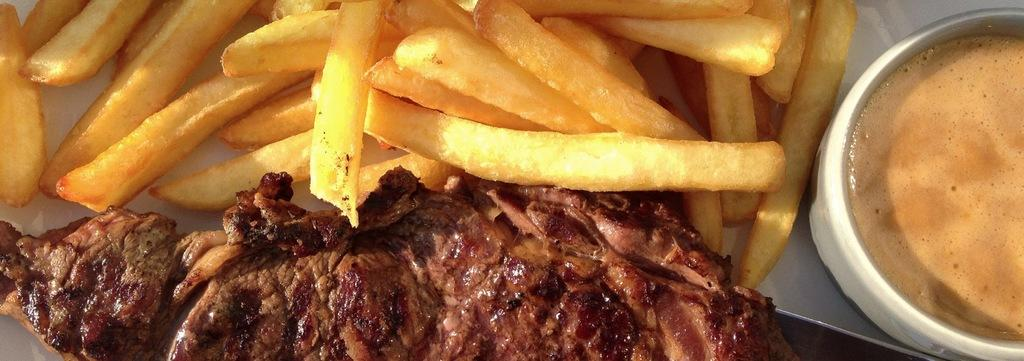What object is located on the right side of the image? There is a cup on the right side of the image. What can be found on the plate in the image? There is a plate with a food item in the image. What type of bomb is depicted on the plate in the image? There is no bomb present on the plate or in the image. What does the frog believe about the food item on the plate? There is no frog present in the image, so it is not possible to determine what the frog believes about the food item. 